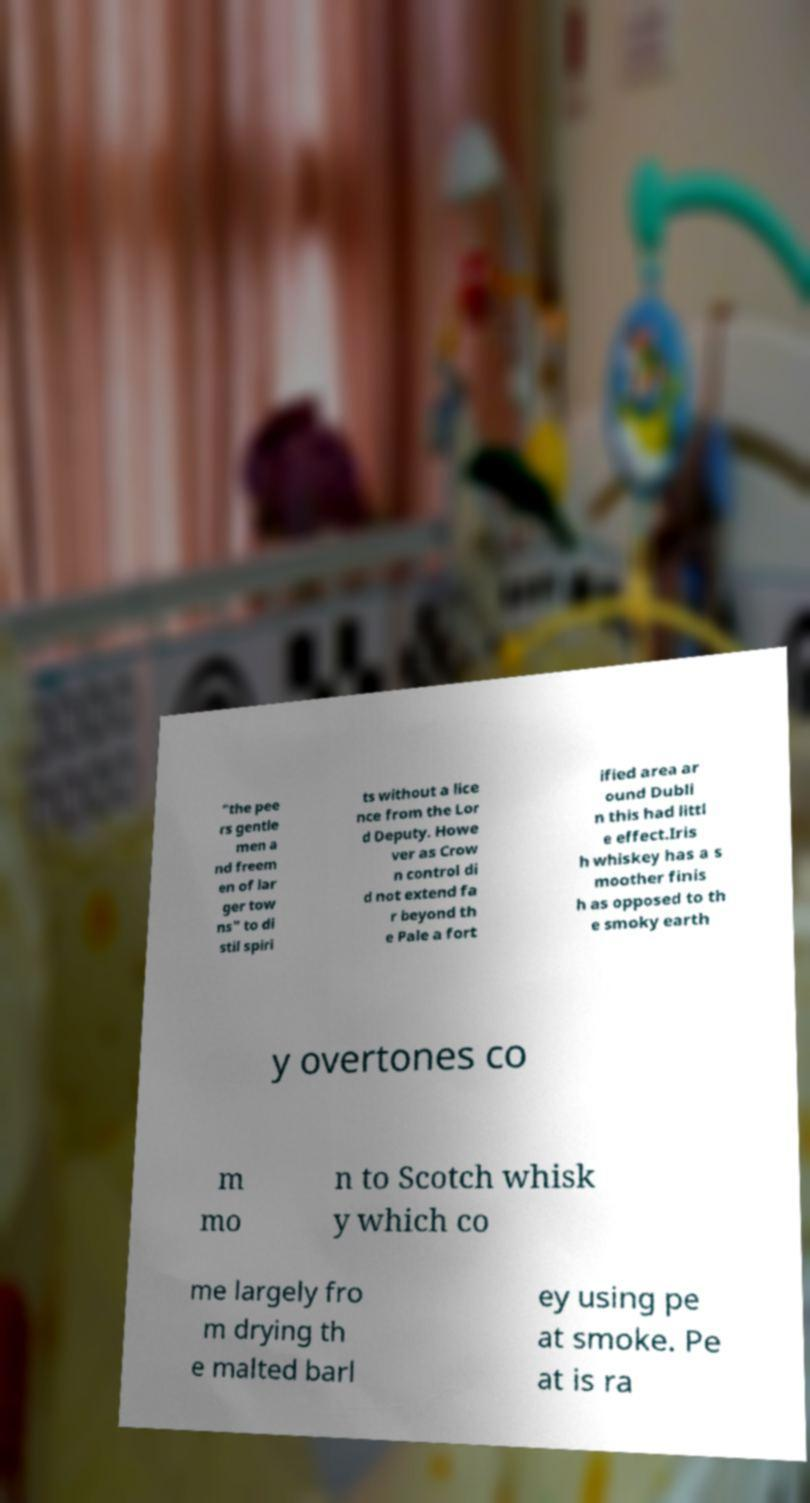Please read and relay the text visible in this image. What does it say? "the pee rs gentle men a nd freem en of lar ger tow ns" to di stil spiri ts without a lice nce from the Lor d Deputy. Howe ver as Crow n control di d not extend fa r beyond th e Pale a fort ified area ar ound Dubli n this had littl e effect.Iris h whiskey has a s moother finis h as opposed to th e smoky earth y overtones co m mo n to Scotch whisk y which co me largely fro m drying th e malted barl ey using pe at smoke. Pe at is ra 